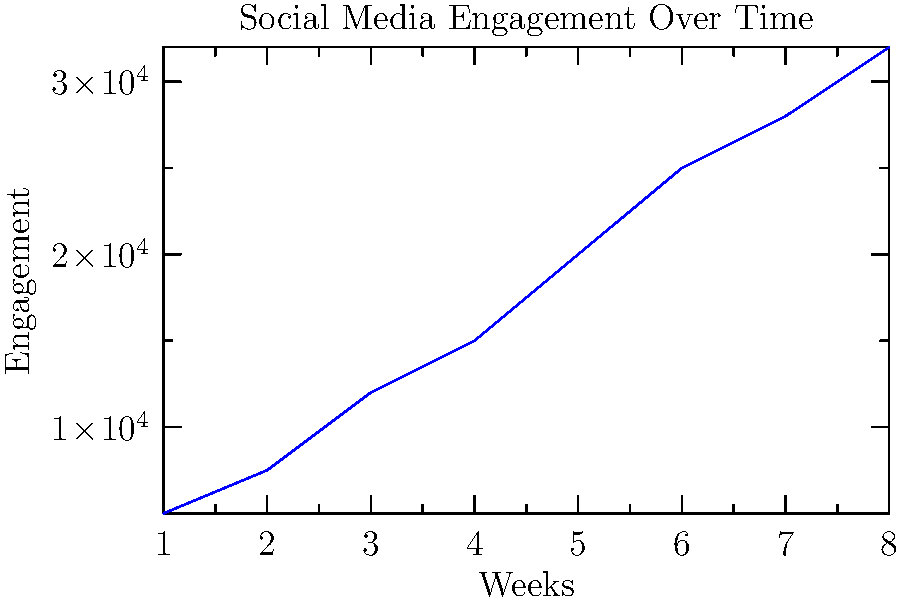As a PR representative for the "One Nation" progressive gathering, you're analyzing the trend of social media engagement over the past 8 weeks. The graph shows the number of interactions (likes, comments, shares) on your posts each week. If the trend continues at the same rate, approximately how many interactions can you expect in week 10? To solve this problem, we need to follow these steps:

1. Analyze the trend:
   The graph shows an increasing trend in social media engagement over 8 weeks.

2. Calculate the average weekly increase:
   - Week 1: 5,000 interactions
   - Week 8: 32,000 interactions
   - Total increase: 32,000 - 5,000 = 27,000 interactions
   - Average weekly increase: 27,000 ÷ 7 = 3,857 interactions per week

3. Extend the trend for two more weeks:
   - Week 9 estimate: 32,000 + 3,857 = 35,857 interactions
   - Week 10 estimate: 35,857 + 3,857 = 39,714 interactions

4. Round the result:
   39,714 rounds to approximately 40,000 interactions

Therefore, if the trend continues at the same rate, you can expect approximately 40,000 interactions in week 10.
Answer: Approximately 40,000 interactions 